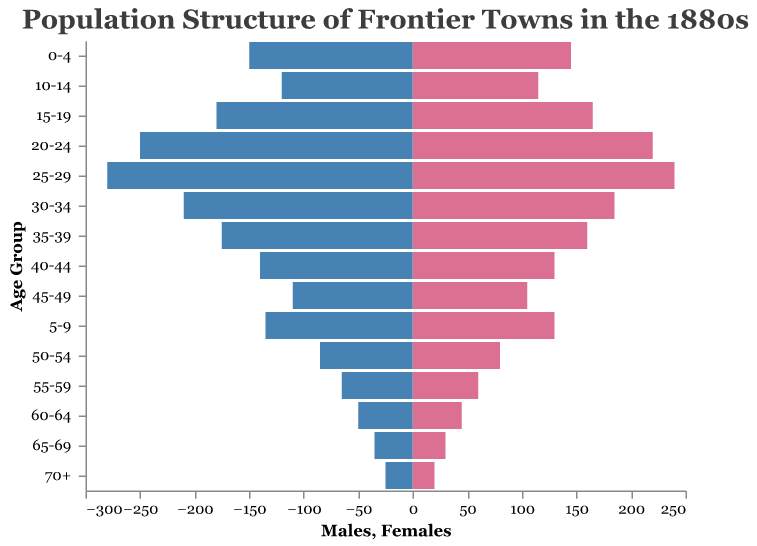What is the most populous age group for males? The population pyramid displays the number of males in different age groups by bar lengths. The age group with the longest bar for males indicates the highest population. In this case, the 25-29 age group has the longest bar.
Answer: 25-29 Which age group has an almost equal population for both males and females? To find the age group with almost equal populations, we compare the lengths of the bars for males and females in each age group. The age group 0-4 has a male population of 150 and a female population of 145, which are nearly equal.
Answer: 0-4 What can be inferred about the age distribution of the frontier town in the 1880s? The population pyramid shows a larger number of young adults (ages 15-34) compared to older age groups. This suggests an influx of young workers and families, with fewer older residents likely due to the demanding and often harsh living conditions.
Answer: Influx of young workers and families, fewer older residents How does the population of males in the 20-24 age group compare to that in the 65-69 age group? By comparing the lengths of the bars corresponding to these age groups, we see that the 20-24 age group has a female population of 220, while the 65-69 age group has only 30 females. This indicates the younger age group has a much higher population.
Answer: 220 to 30 Which gender has a larger overall population in the frontier town? By visually inspecting and summing the lengths of bars for both genders across all age groups, it is clear that males have a larger overall population compared to females.
Answer: Males What is the difference in the number of males between the 0-4 and 25-29 age groups? The population pyramid indicates that the 0-4 age group has 150 males, and the 25-29 age group has 280 males. Subtracting these gives us a difference of 130 males.
Answer: 130 Which age group shows a significant decrease in the population for both genders after the age of 34? Observing the population pyramid, we notice a significant drop in population for both males and females starting at the 35-39 age group.
Answer: 35-39 What is the combined population of females in the 20-24 and 25-29 age groups? The population pyramid indicates 220 females in the 20-24 age group and 240 in the 25-29 age group. Adding these totals gives a combined population of 460 females.
Answer: 460 What is the total population for the age group 70+? The population pyramid shows 25 males and 20 females in the 70+ age group. The total population is obtained by summing these numbers: 25 + 20 = 45.
Answer: 45 